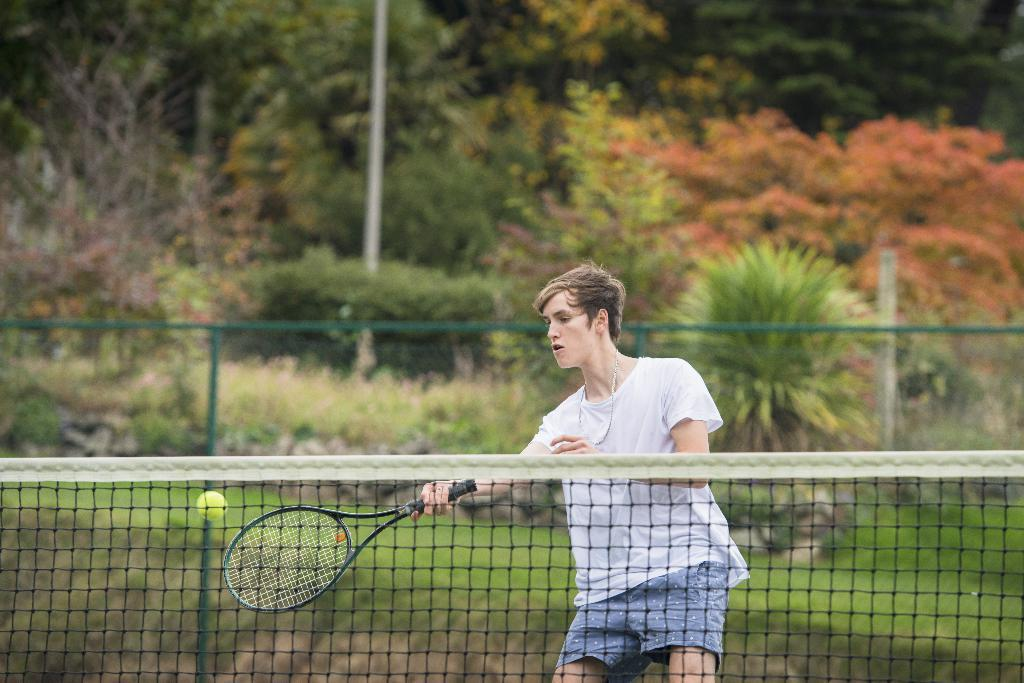What is the man in the image holding? The man is holding a bat in the image. What other objects can be seen in the image? There is a ball and a net in the image. What is visible in the background of the image? There is a fence, plants, and trees in the background of the image. What type of whistle is the servant using to communicate with the prisoners in the image? There is no servant, whistle, or prisoners present in the image. 